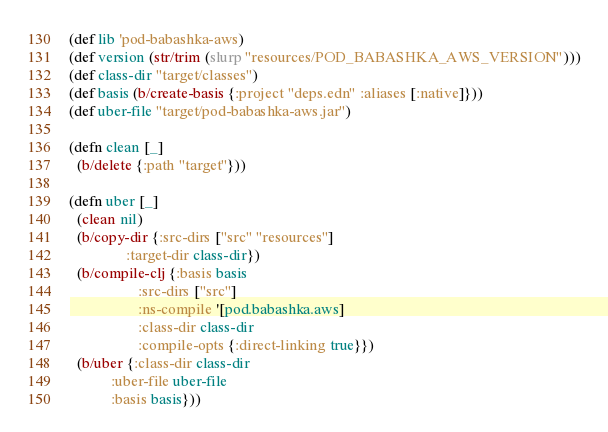Convert code to text. <code><loc_0><loc_0><loc_500><loc_500><_Clojure_>(def lib 'pod-babashka-aws)
(def version (str/trim (slurp "resources/POD_BABASHKA_AWS_VERSION")))
(def class-dir "target/classes")
(def basis (b/create-basis {:project "deps.edn" :aliases [:native]}))
(def uber-file "target/pod-babashka-aws.jar")

(defn clean [_]
  (b/delete {:path "target"}))

(defn uber [_]
  (clean nil)
  (b/copy-dir {:src-dirs ["src" "resources"]
               :target-dir class-dir})
  (b/compile-clj {:basis basis
                  :src-dirs ["src"]
                  :ns-compile '[pod.babashka.aws]
                  :class-dir class-dir
                  :compile-opts {:direct-linking true}})
  (b/uber {:class-dir class-dir
           :uber-file uber-file
           :basis basis}))
</code> 